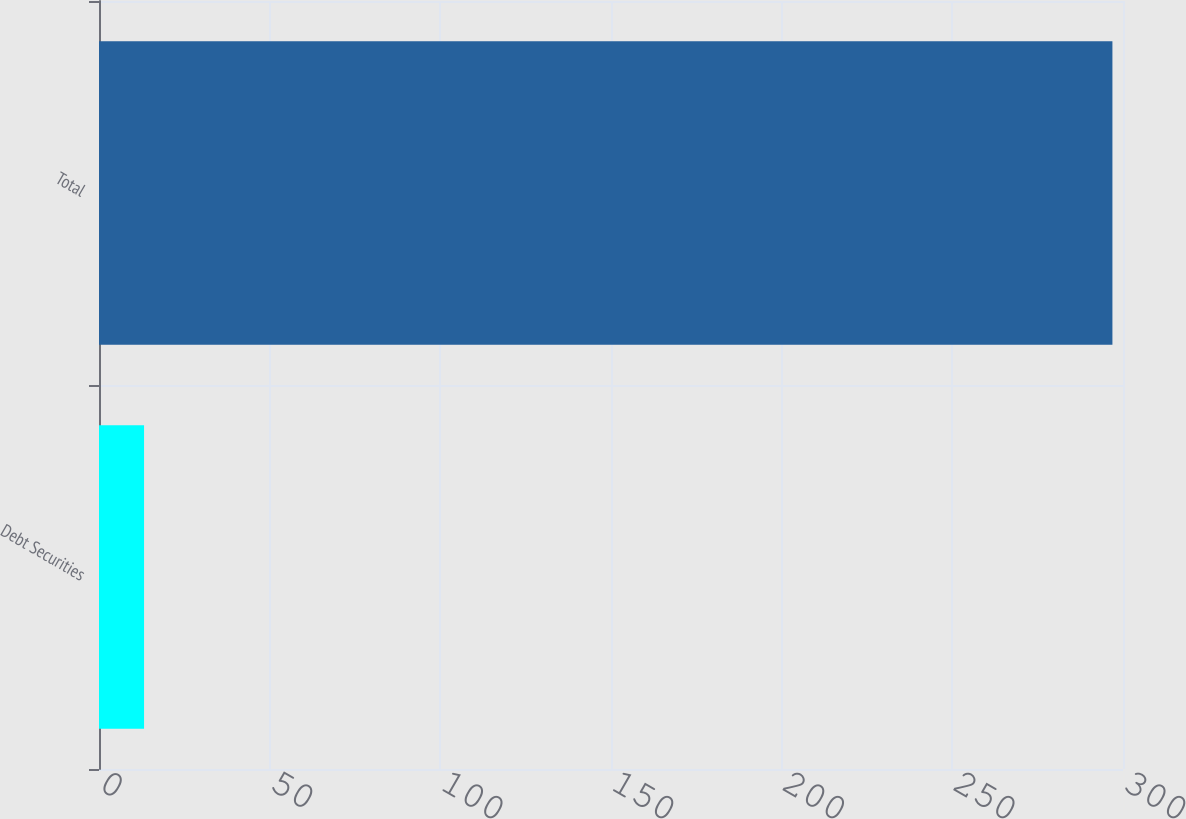<chart> <loc_0><loc_0><loc_500><loc_500><bar_chart><fcel>Debt Securities<fcel>Total<nl><fcel>13.2<fcel>296.9<nl></chart> 